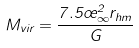<formula> <loc_0><loc_0><loc_500><loc_500>M _ { v i r } = \frac { 7 . 5 \sigma _ { \infty } ^ { 2 } r _ { h m } } { G }</formula> 